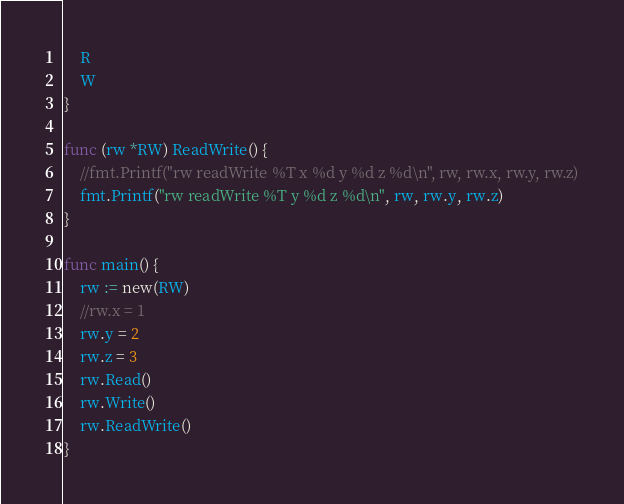Convert code to text. <code><loc_0><loc_0><loc_500><loc_500><_Go_>	R
	W
}

func (rw *RW) ReadWrite() {
	//fmt.Printf("rw readWrite %T x %d y %d z %d\n", rw, rw.x, rw.y, rw.z)
	fmt.Printf("rw readWrite %T y %d z %d\n", rw, rw.y, rw.z)
}

func main() {
	rw := new(RW)
	//rw.x = 1
	rw.y = 2
	rw.z = 3
	rw.Read()
	rw.Write()
	rw.ReadWrite()
}
</code> 